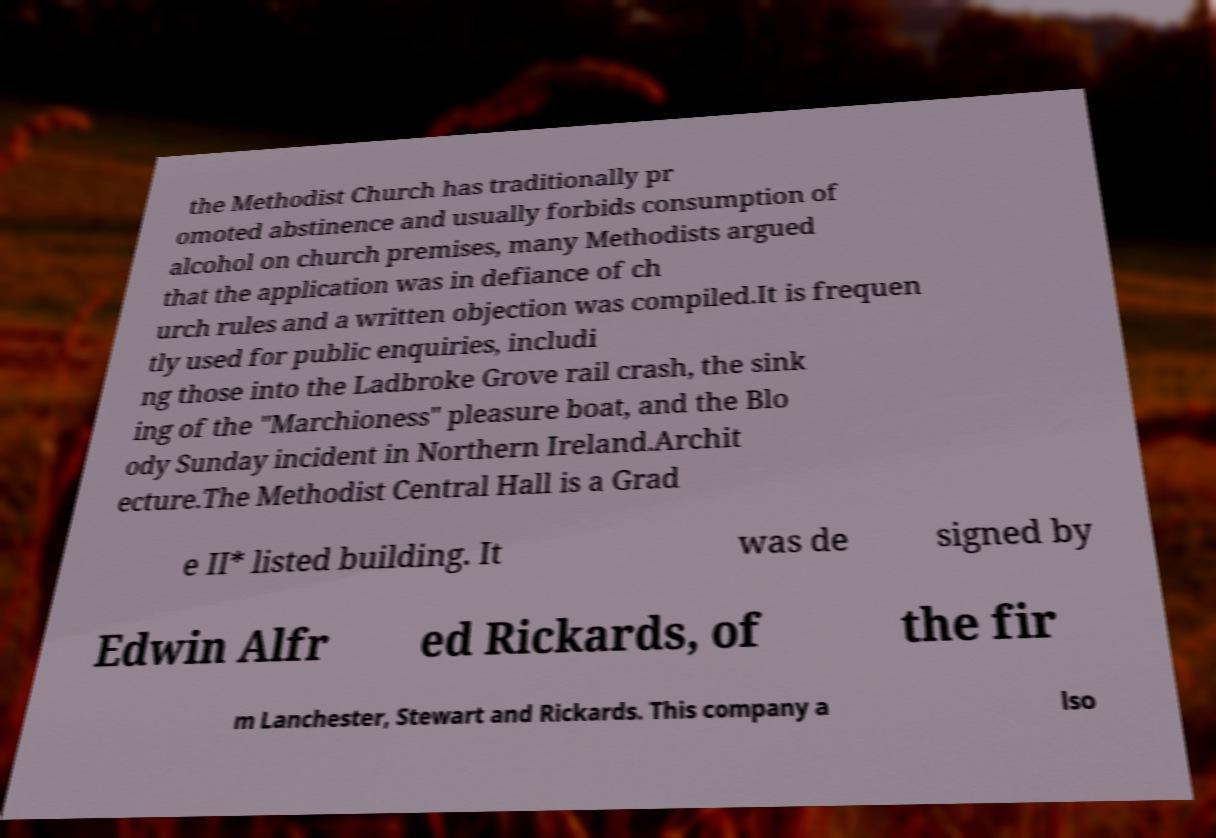There's text embedded in this image that I need extracted. Can you transcribe it verbatim? the Methodist Church has traditionally pr omoted abstinence and usually forbids consumption of alcohol on church premises, many Methodists argued that the application was in defiance of ch urch rules and a written objection was compiled.It is frequen tly used for public enquiries, includi ng those into the Ladbroke Grove rail crash, the sink ing of the "Marchioness" pleasure boat, and the Blo ody Sunday incident in Northern Ireland.Archit ecture.The Methodist Central Hall is a Grad e II* listed building. It was de signed by Edwin Alfr ed Rickards, of the fir m Lanchester, Stewart and Rickards. This company a lso 